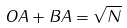Convert formula to latex. <formula><loc_0><loc_0><loc_500><loc_500>O A + B A = \sqrt { N }</formula> 